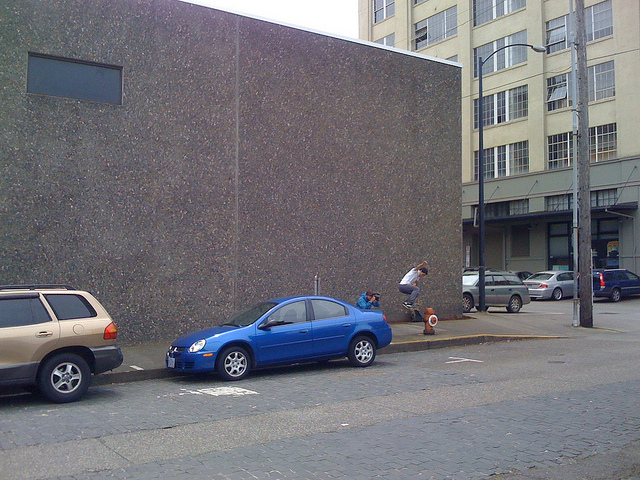Identify the text contained in this image. y 